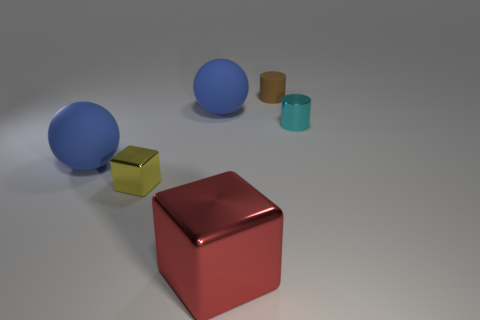Does the brown cylinder have the same size as the blue rubber ball in front of the cyan thing?
Your answer should be compact. No. Are there any red metallic objects on the right side of the red object in front of the yellow cube?
Give a very brief answer. No. Is there a tiny brown rubber object of the same shape as the cyan metal thing?
Offer a terse response. Yes. How many objects are left of the rubber sphere behind the big matte object in front of the tiny cyan cylinder?
Your response must be concise. 2. There is a big shiny thing; does it have the same color as the small metallic thing that is in front of the cyan shiny cylinder?
Ensure brevity in your answer.  No. How many things are tiny things in front of the tiny brown thing or matte things on the right side of the red shiny thing?
Provide a succinct answer. 3. Are there more metallic objects in front of the tiny metal cylinder than small rubber cylinders in front of the yellow metal thing?
Give a very brief answer. Yes. What material is the sphere that is on the right side of the thing that is on the left side of the small thing that is left of the red shiny cube?
Your answer should be very brief. Rubber. There is a small metal object on the right side of the small metal cube; does it have the same shape as the big red thing to the right of the small yellow metallic block?
Ensure brevity in your answer.  No. Are there any other metal cylinders that have the same size as the brown cylinder?
Keep it short and to the point. Yes. 